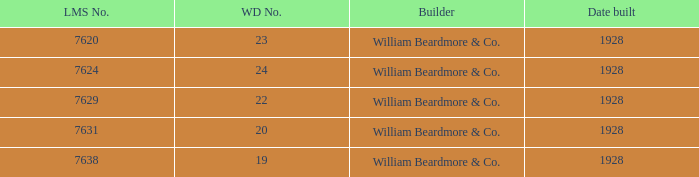Identify the builder responsible for the wd number 22. William Beardmore & Co. Parse the table in full. {'header': ['LMS No.', 'WD No.', 'Builder', 'Date built'], 'rows': [['7620', '23', 'William Beardmore & Co.', '1928'], ['7624', '24', 'William Beardmore & Co.', '1928'], ['7629', '22', 'William Beardmore & Co.', '1928'], ['7631', '20', 'William Beardmore & Co.', '1928'], ['7638', '19', 'William Beardmore & Co.', '1928']]} 